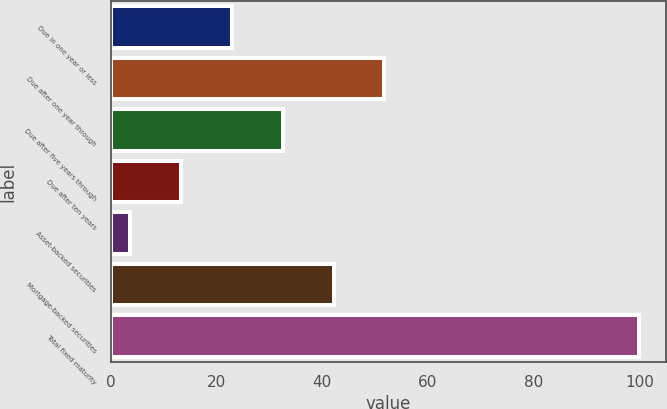Convert chart. <chart><loc_0><loc_0><loc_500><loc_500><bar_chart><fcel>Due in one year or less<fcel>Due after one year through<fcel>Due after five years through<fcel>Due after ten years<fcel>Asset-backed securities<fcel>Mortgage-backed securities<fcel>Total fixed maturity<nl><fcel>22.88<fcel>51.8<fcel>32.52<fcel>13.24<fcel>3.6<fcel>42.16<fcel>100<nl></chart> 